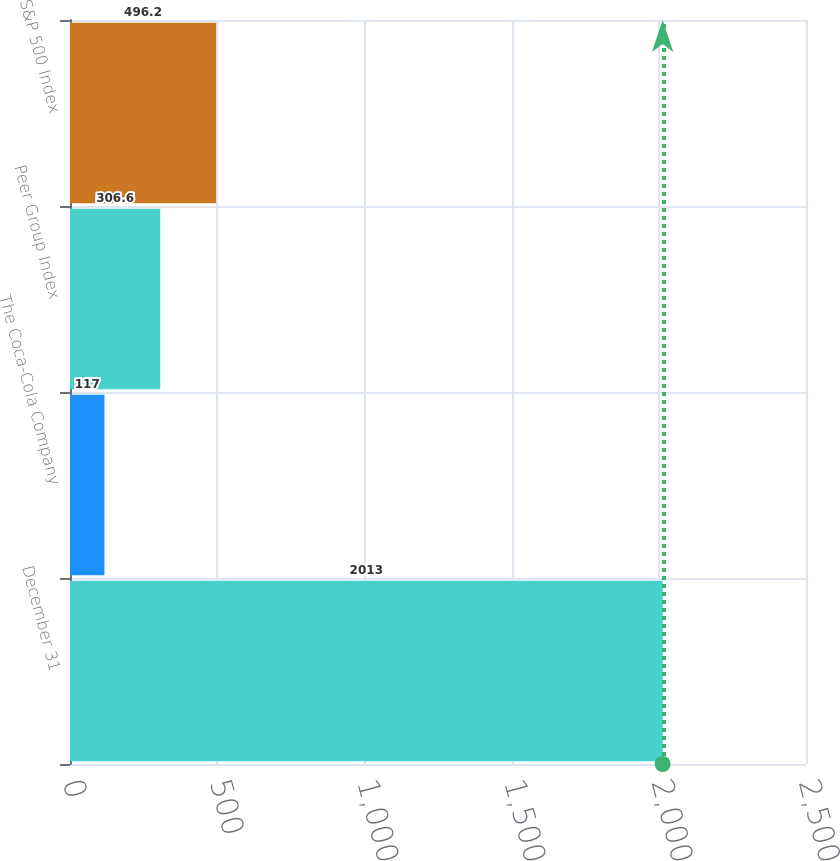Convert chart. <chart><loc_0><loc_0><loc_500><loc_500><bar_chart><fcel>December 31<fcel>The Coca-Cola Company<fcel>Peer Group Index<fcel>S&P 500 Index<nl><fcel>2013<fcel>117<fcel>306.6<fcel>496.2<nl></chart> 